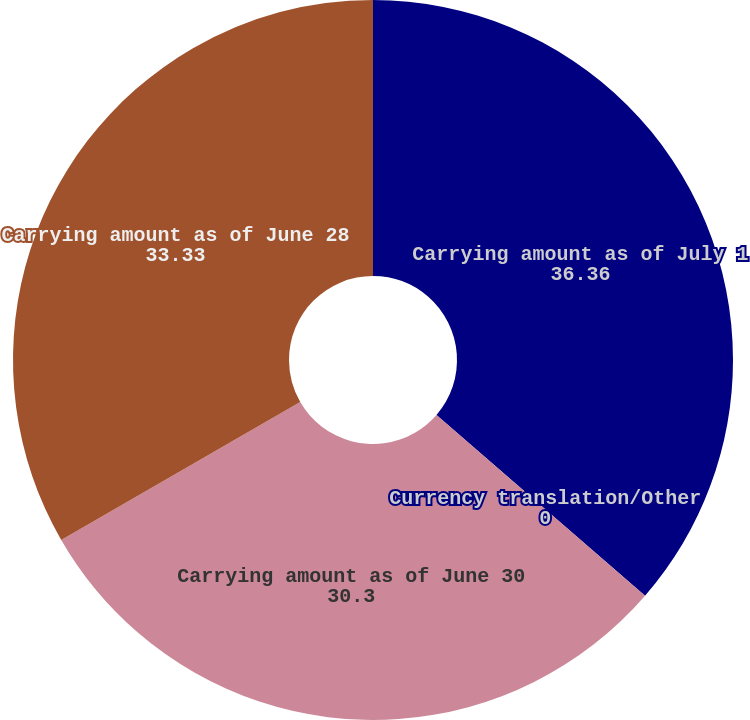Convert chart to OTSL. <chart><loc_0><loc_0><loc_500><loc_500><pie_chart><fcel>Carrying amount as of July 1<fcel>Currency translation/Other<fcel>Carrying amount as of June 30<fcel>Carrying amount as of June 28<nl><fcel>36.36%<fcel>0.0%<fcel>30.3%<fcel>33.33%<nl></chart> 